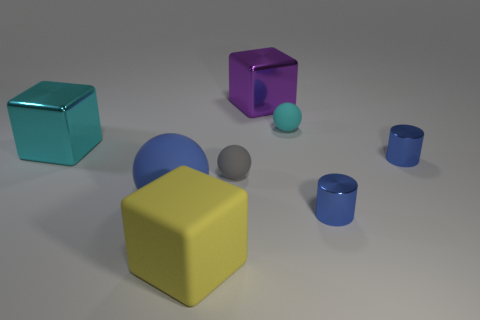Add 1 large purple cubes. How many objects exist? 9 Subtract all balls. How many objects are left? 5 Add 1 yellow cubes. How many yellow cubes are left? 2 Add 5 tiny cyan blocks. How many tiny cyan blocks exist? 5 Subtract 0 gray cylinders. How many objects are left? 8 Subtract all tiny blue metal objects. Subtract all big matte things. How many objects are left? 4 